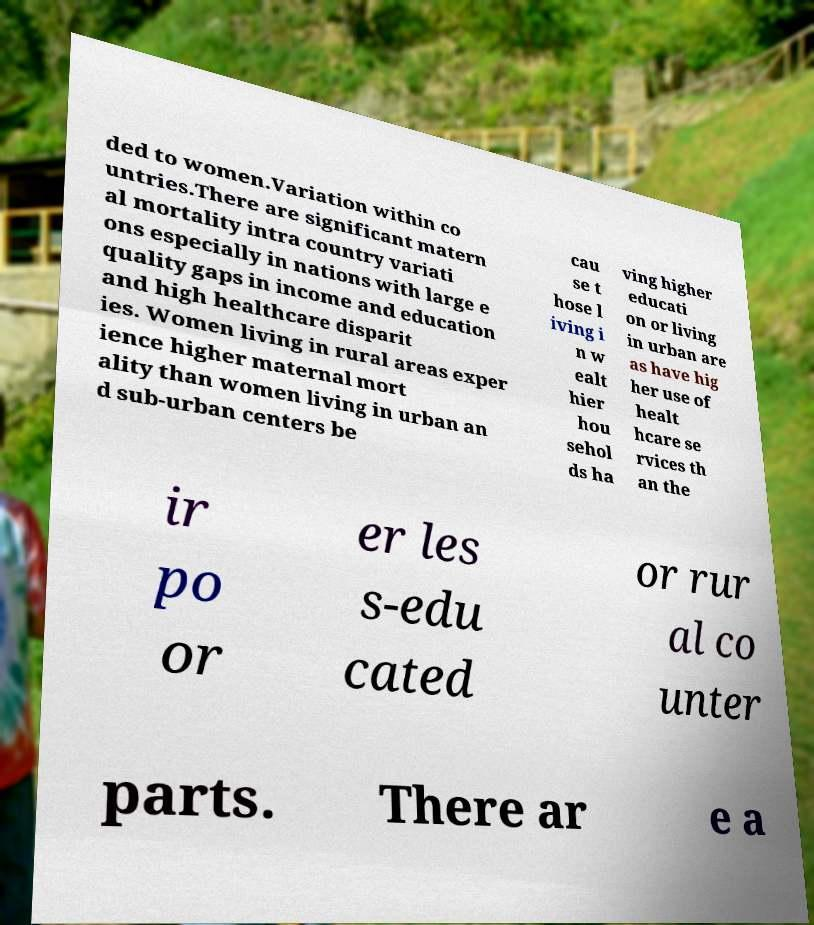Please identify and transcribe the text found in this image. ded to women.Variation within co untries.There are significant matern al mortality intra country variati ons especially in nations with large e quality gaps in income and education and high healthcare disparit ies. Women living in rural areas exper ience higher maternal mort ality than women living in urban an d sub-urban centers be cau se t hose l iving i n w ealt hier hou sehol ds ha ving higher educati on or living in urban are as have hig her use of healt hcare se rvices th an the ir po or er les s-edu cated or rur al co unter parts. There ar e a 